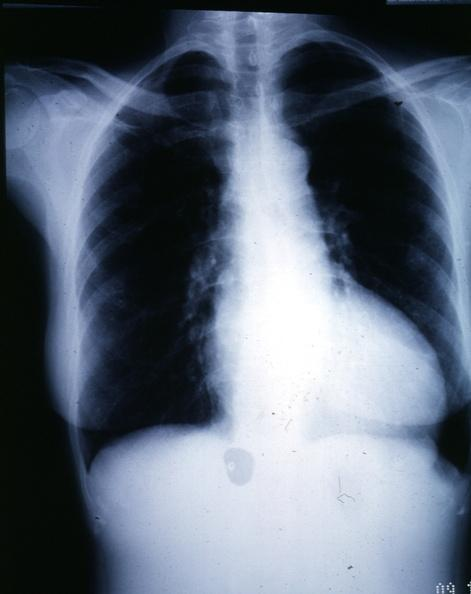does peritoneal fluid show x-ray epa chest with obvious cardiomegaly female with aortic valve stenosis?
Answer the question using a single word or phrase. No 